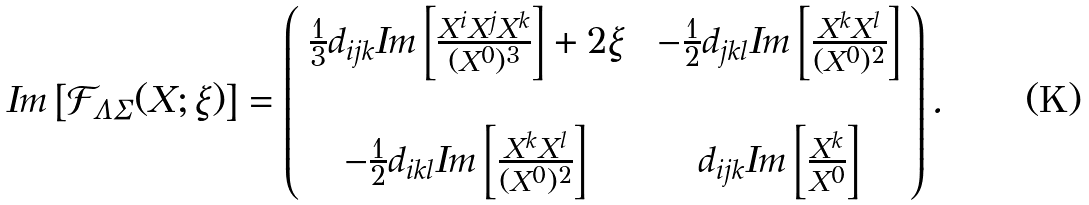Convert formula to latex. <formula><loc_0><loc_0><loc_500><loc_500>I m \left [ \mathcal { F } _ { \Lambda \Sigma } ( X ; \xi ) \right ] = \left ( \begin{array} { c c c } \frac { 1 } { 3 } d _ { i j k } I m \left [ \frac { X ^ { i } X ^ { j } X ^ { k } } { ( X ^ { 0 } ) ^ { 3 } } \right ] + 2 \xi & & - \frac { 1 } { 2 } d _ { j k l } I m \left [ \frac { X ^ { k } X ^ { l } } { ( X ^ { 0 } ) ^ { 2 } } \right ] \\ & & \\ - \frac { 1 } { 2 } d _ { i k l } I m \left [ \frac { X ^ { k } X ^ { l } } { ( X ^ { 0 } ) ^ { 2 } } \right ] & & d _ { i j k } I m \left [ \frac { X ^ { k } } { X ^ { 0 } } \right ] \end{array} \right ) .</formula> 